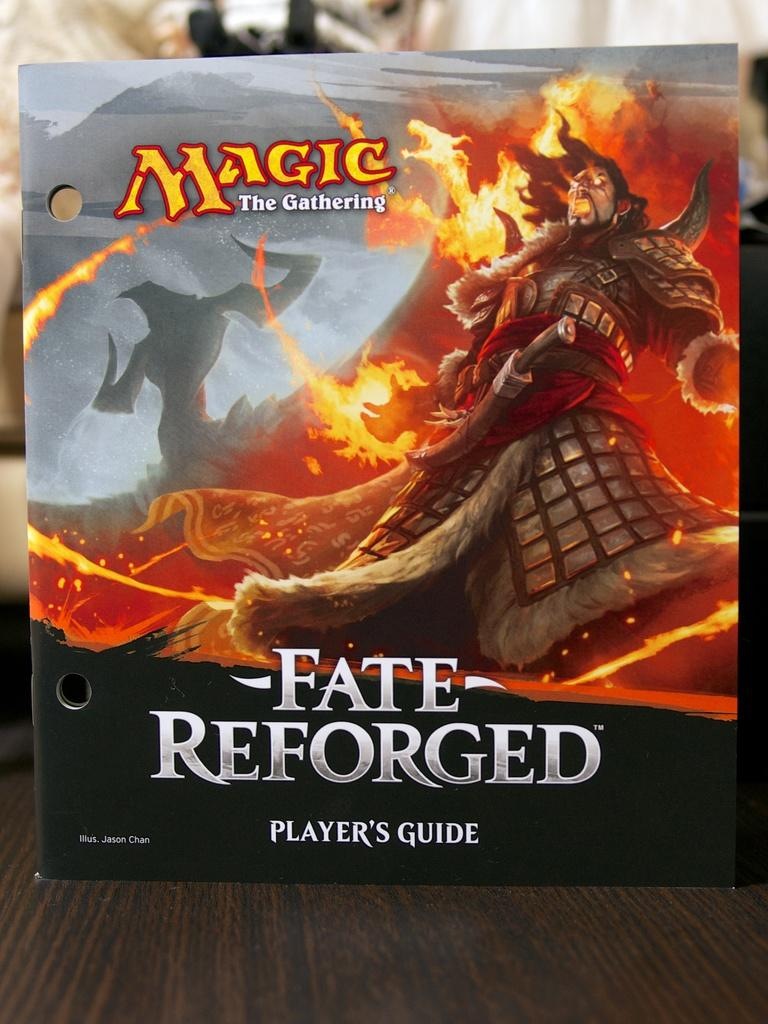<image>
Give a short and clear explanation of the subsequent image. The player's guide for Fate Reforged shows a man surrounded by fire. 